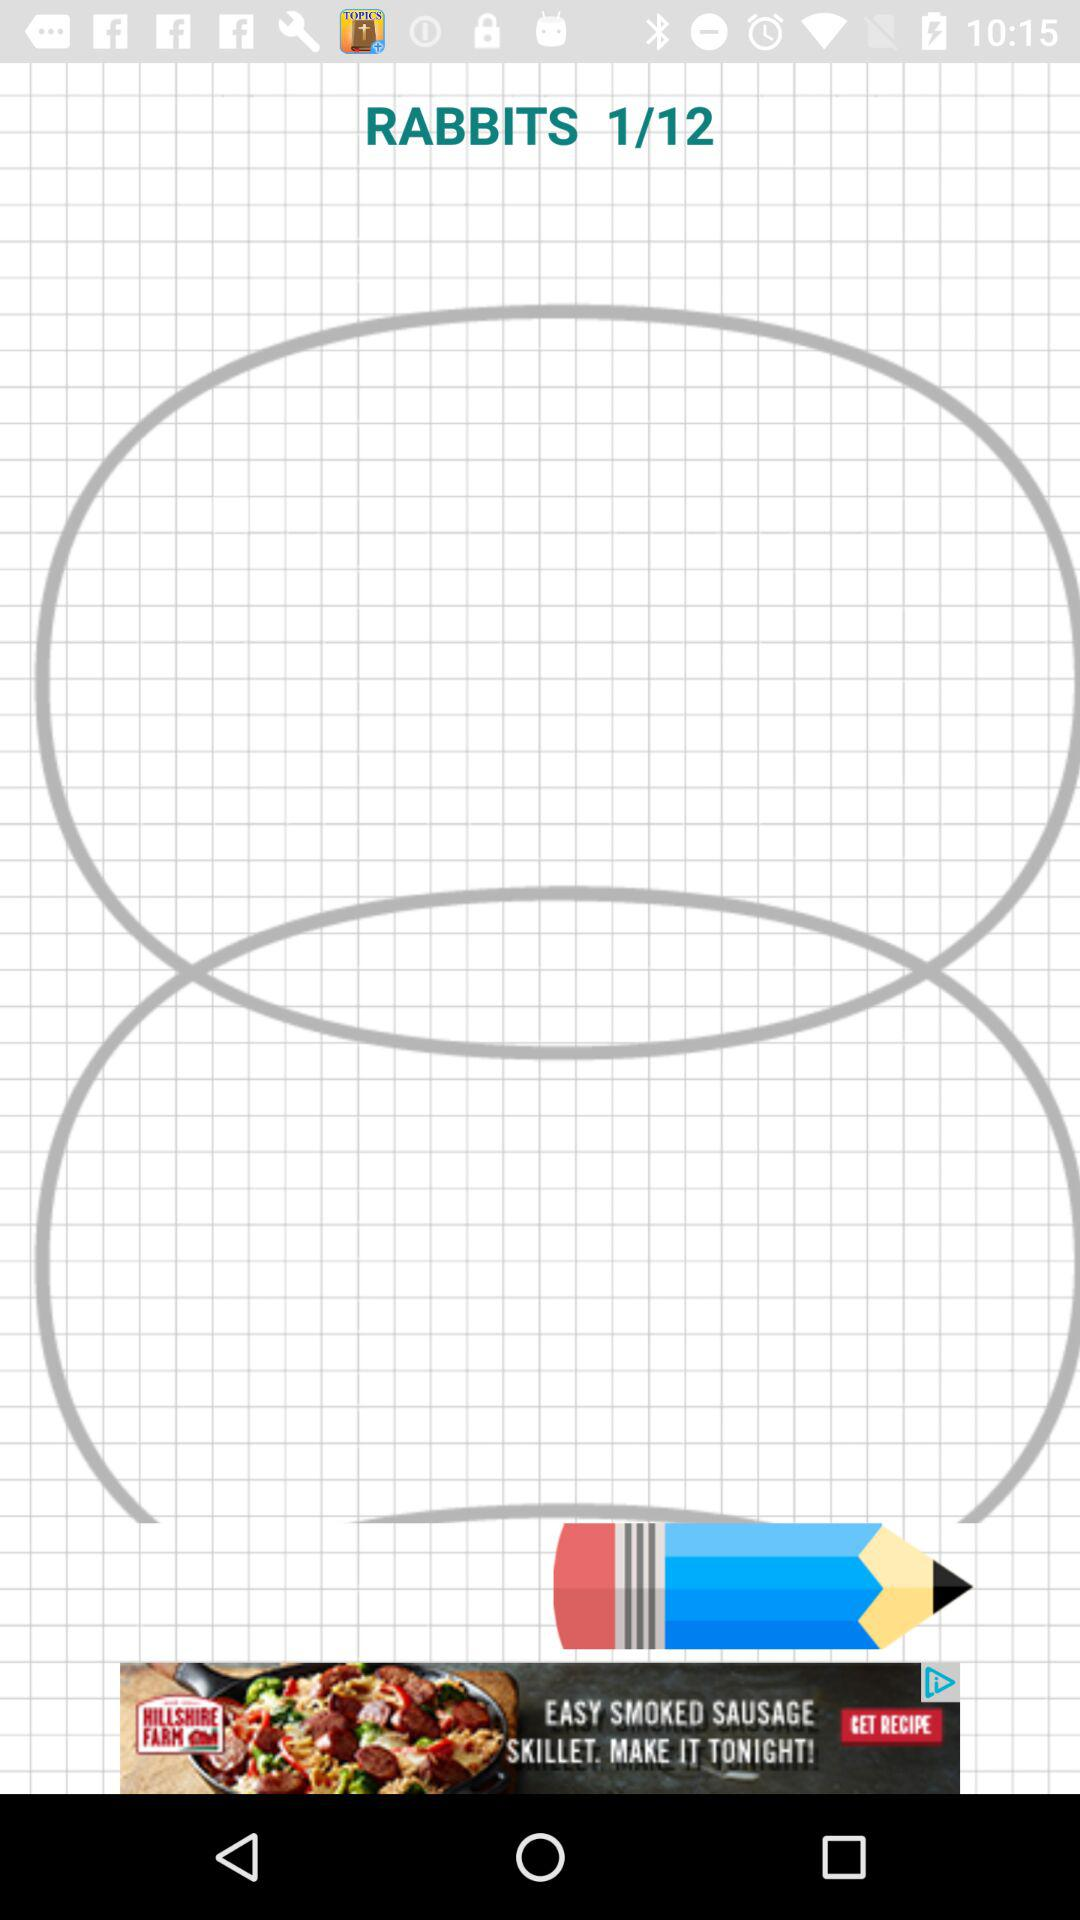At which "RABBITS" page am I? You are at the first page. 